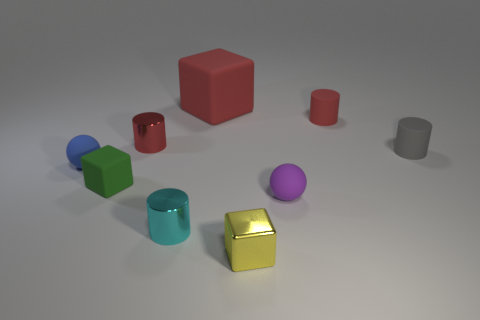Subtract all red metallic cylinders. How many cylinders are left? 3 Subtract all brown cylinders. Subtract all red blocks. How many cylinders are left? 4 Add 1 small blue metallic things. How many objects exist? 10 Subtract all cubes. How many objects are left? 6 Add 9 small gray matte cylinders. How many small gray matte cylinders are left? 10 Add 8 small blue objects. How many small blue objects exist? 9 Subtract 0 green cylinders. How many objects are left? 9 Subtract all green objects. Subtract all tiny matte balls. How many objects are left? 6 